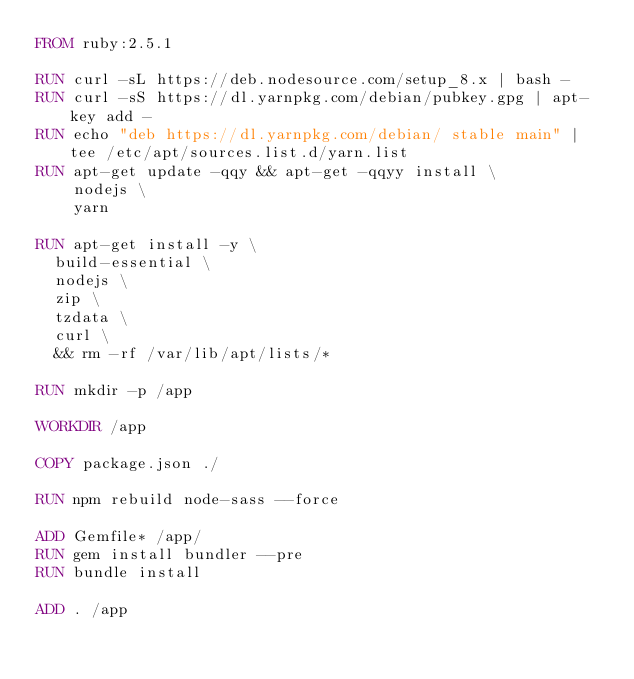Convert code to text. <code><loc_0><loc_0><loc_500><loc_500><_Dockerfile_>FROM ruby:2.5.1

RUN curl -sL https://deb.nodesource.com/setup_8.x | bash -
RUN curl -sS https://dl.yarnpkg.com/debian/pubkey.gpg | apt-key add -
RUN echo "deb https://dl.yarnpkg.com/debian/ stable main" | tee /etc/apt/sources.list.d/yarn.list
RUN apt-get update -qqy && apt-get -qqyy install \
    nodejs \
    yarn

RUN apt-get install -y \ 
  build-essential \ 
  nodejs \
  zip \
  tzdata \
  curl \
  && rm -rf /var/lib/apt/lists/*

RUN mkdir -p /app
  
WORKDIR /app

COPY package.json ./

RUN npm rebuild node-sass --force

ADD Gemfile* /app/
RUN gem install bundler --pre
RUN bundle install

ADD . /app
</code> 